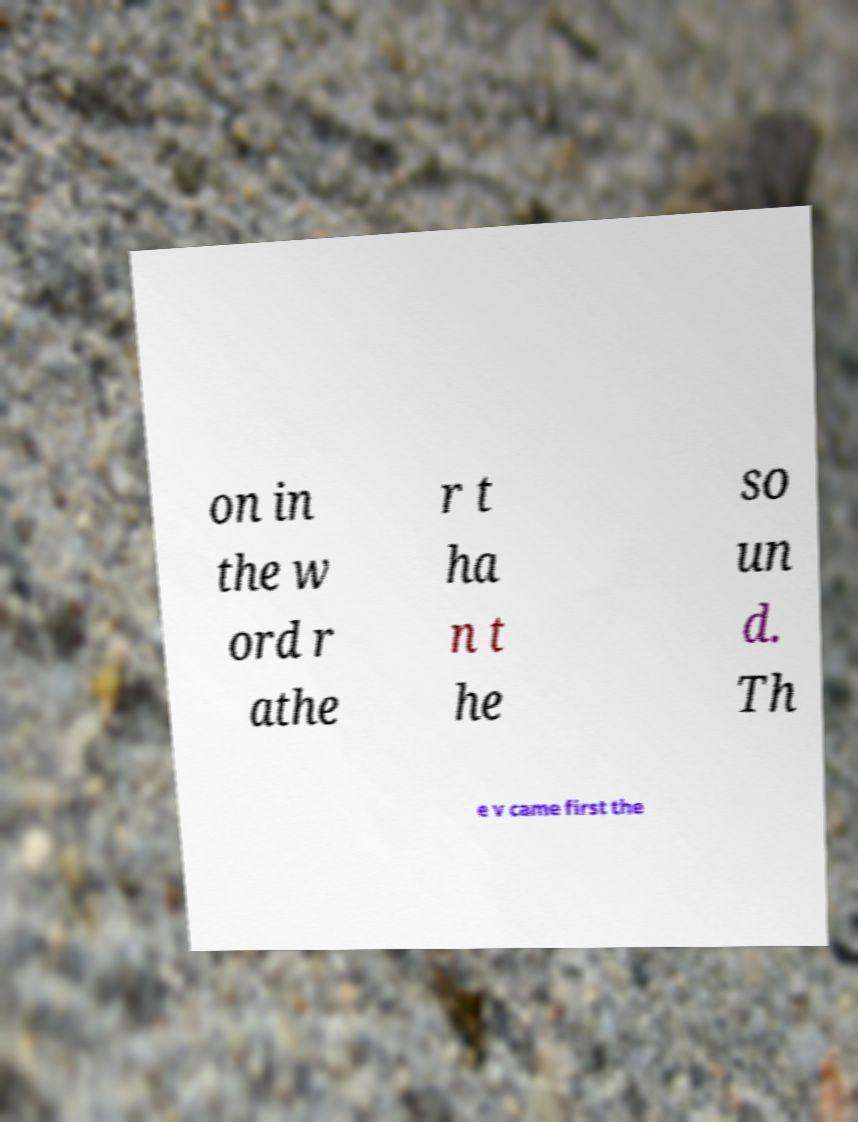Please read and relay the text visible in this image. What does it say? on in the w ord r athe r t ha n t he so un d. Th e v came first the 